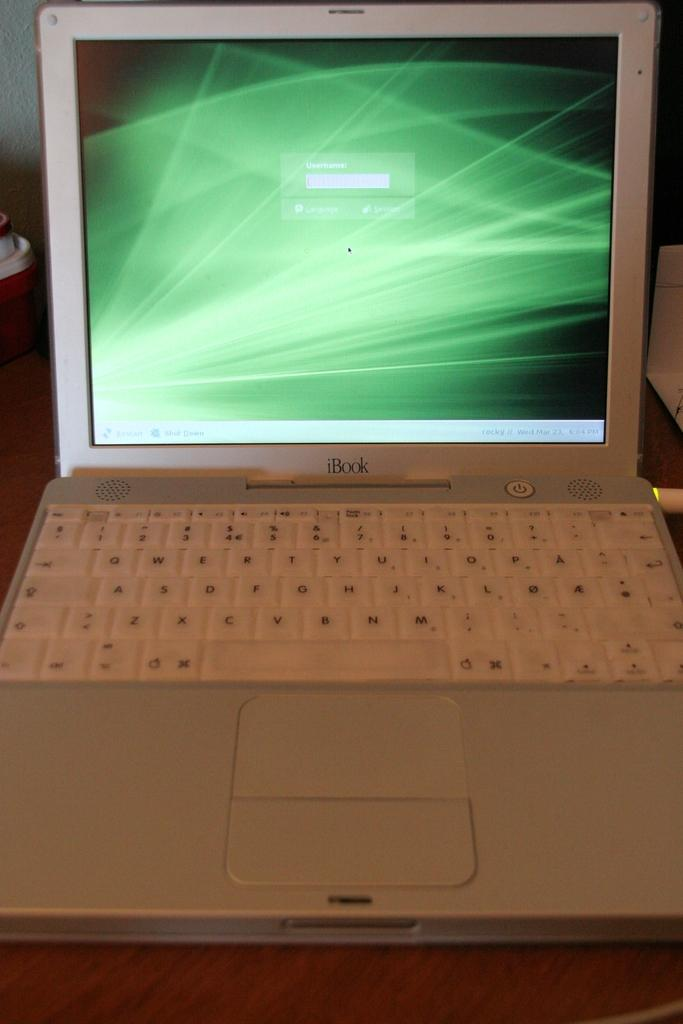Provide a one-sentence caption for the provided image. An old school iBook laptop computer that is open. 